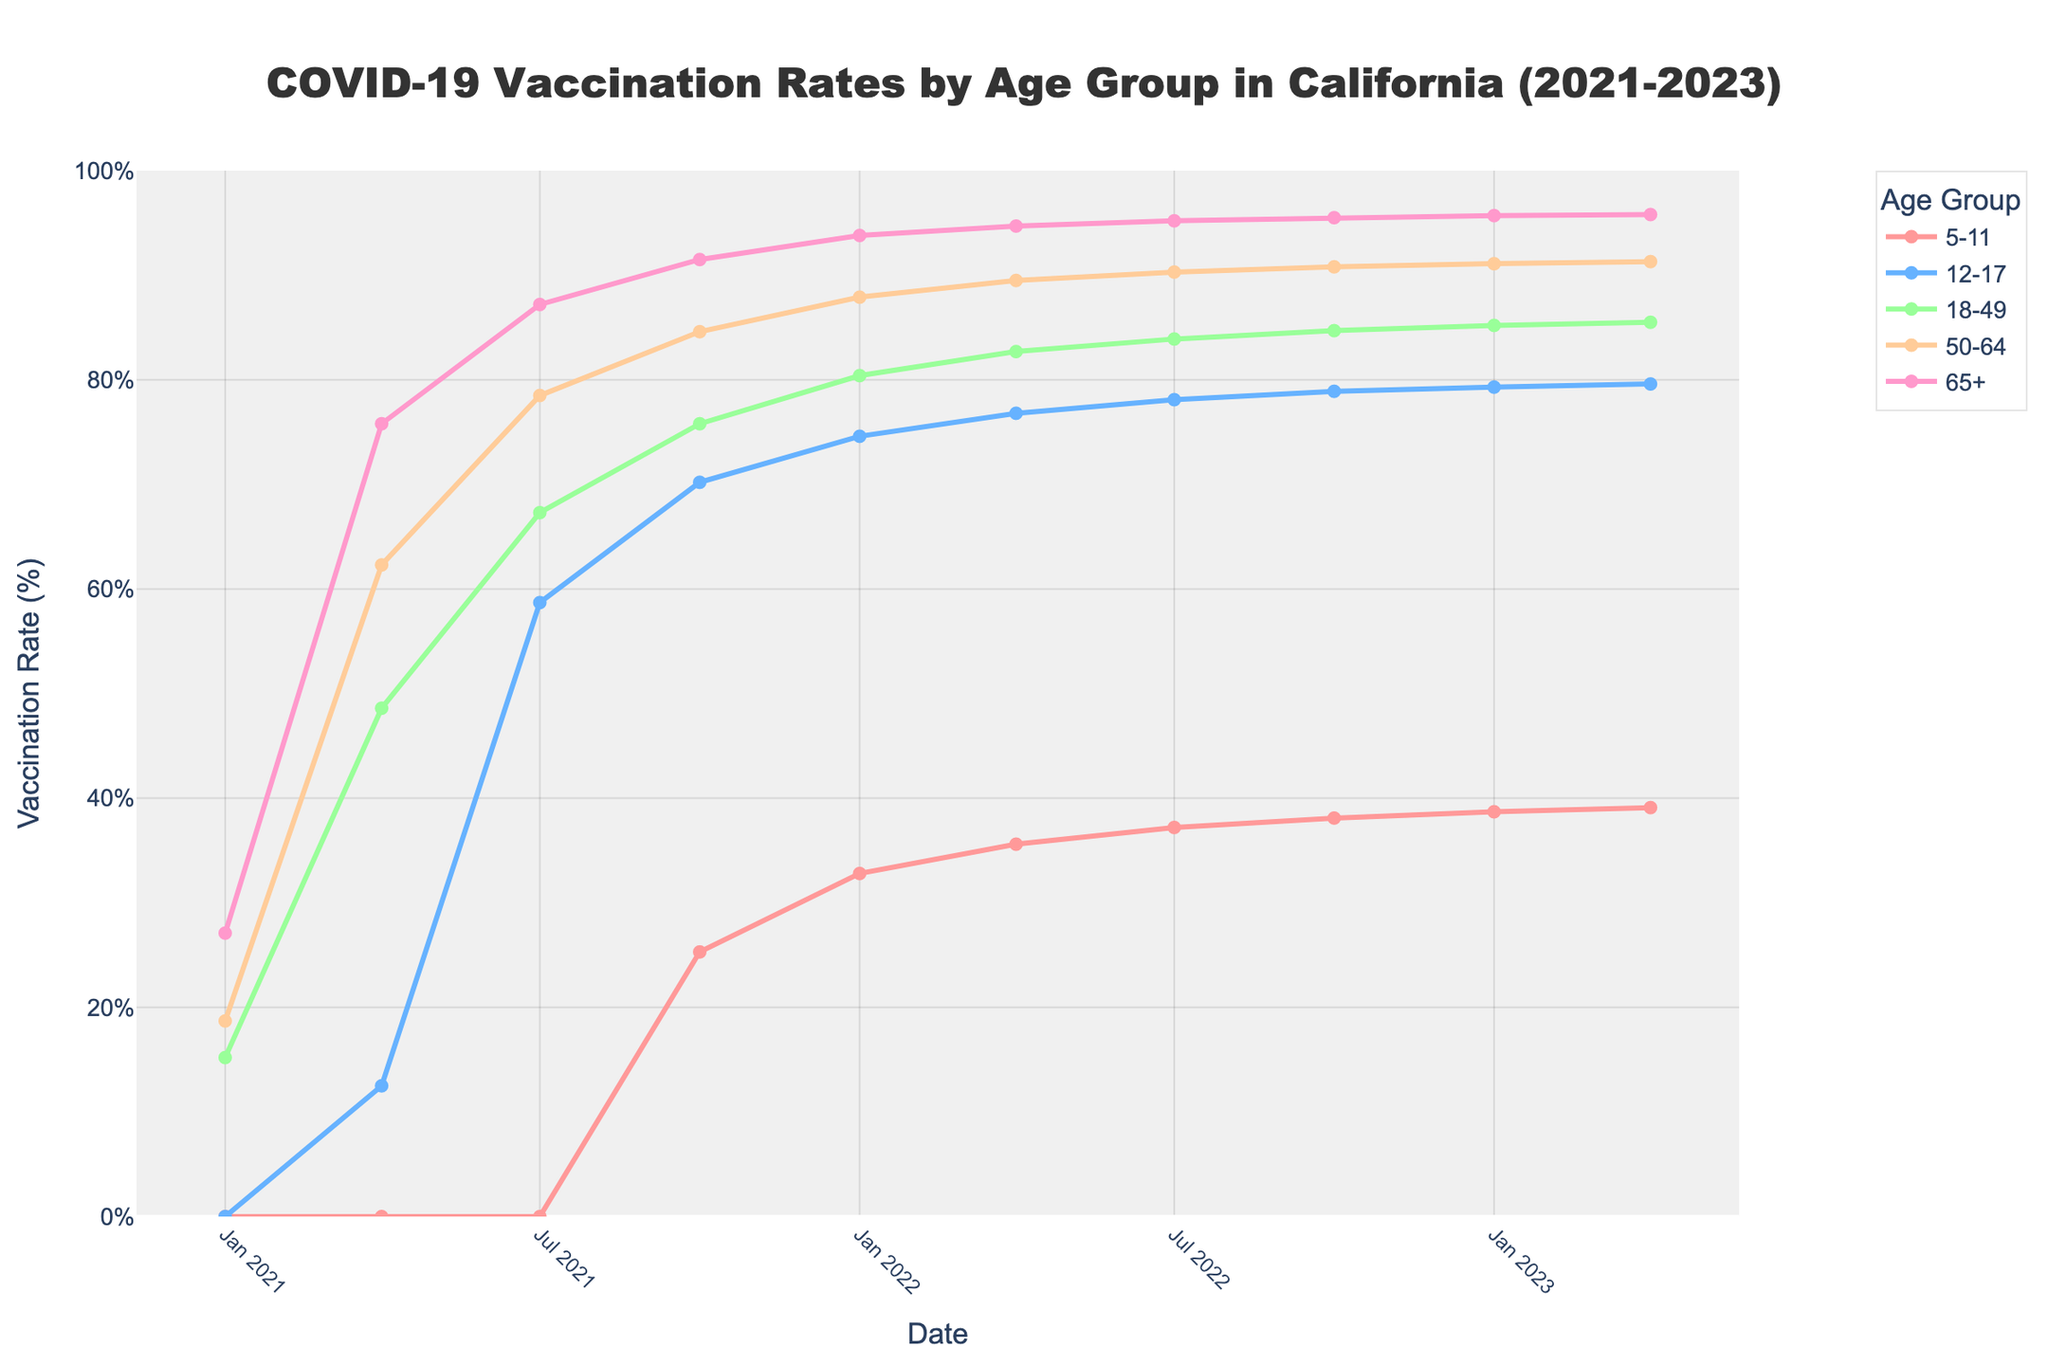What's the highest vaccination rate observed for the 65+ age group? To determine the highest vaccination rate for the 65+ age group, refer to the line representing the 65+ age group and find the maximum point on the y-axis. The highest rate is observed at 95.8% in April 2023.
Answer: 95.8% Which age group showed the most significant increase in vaccination rates from January 2021 to April 2023? Compare the vaccination rates for each age group between January 2021 and April 2023. The 12-17 age group increased from 0% to 79.6%, the highest percentage increase among the groups.
Answer: 12-17 By how much did the vaccination rate for the 50-64 age group increase between January 2022 and April 2023? Check the vaccination rates for the 50-64 age group in January 2022 and April 2023, which are 87.9% and 91.3%, respectively. The increase is 91.3% - 87.9% = 3.4%.
Answer: 3.4% Which age group reached a 50% vaccination rate the earliest? Find each age group's first point of data where the vaccination rate reaches or exceeds 50%. The 12-17 age group reached this point in July 2021 at 58.7%.
Answer: 12-17 Which age group had the lowest vaccination rate in July 2021? Compare the vaccination rates for each age group in July 2021. The 5-11 age group had 0%, which is the lowest at that time point.
Answer: 5-11 How much did the vaccination rate for the 18-49 age group grow from April 2021 to July 2021? To determine the increase, examine the 18-49 age group's rates in April 2021 (48.6%) and July 2021 (67.3%). The rate of growth is 67.3% - 48.6% = 18.7%.
Answer: 18.7% What is the difference in the vaccination rate between the 5-11 age group and the 65+ age group in April 2022? Check the rates for these groups in April 2022: 35.6% for 5-11 and 94.7% for 65+. The difference is 94.7% - 35.6% = 59.1%.
Answer: 59.1% Which age group had a consistent increase in vaccination rates from January 2021 to April 2023 without any decline? Visually inspect the trend lines for each age group to identify one without any decline. The 65+ age group shows a consistent upward trend throughout the entire period.
Answer: 65+ Between July 2022 and January 2023, which age group showed the smallest increase in their vaccination rate? Compare the vaccination rate increments for each age group between these time points. The 5-11 age group went from 37.2% to 38.7%, an increase of 1.5%, which is the smallest.
Answer: 5-11 What's the average vaccination rate across all age groups in January 2023? Calculate the vaccination rates for each age group in January 2023: 38.7%, 79.3%, 85.2%, 91.1%, 95.7%. Sum these rates and divide by the number of groups: (38.7 + 79.3 + 85.2 + 91.1 + 95.7) / 5 = 78%.
Answer: 78% 